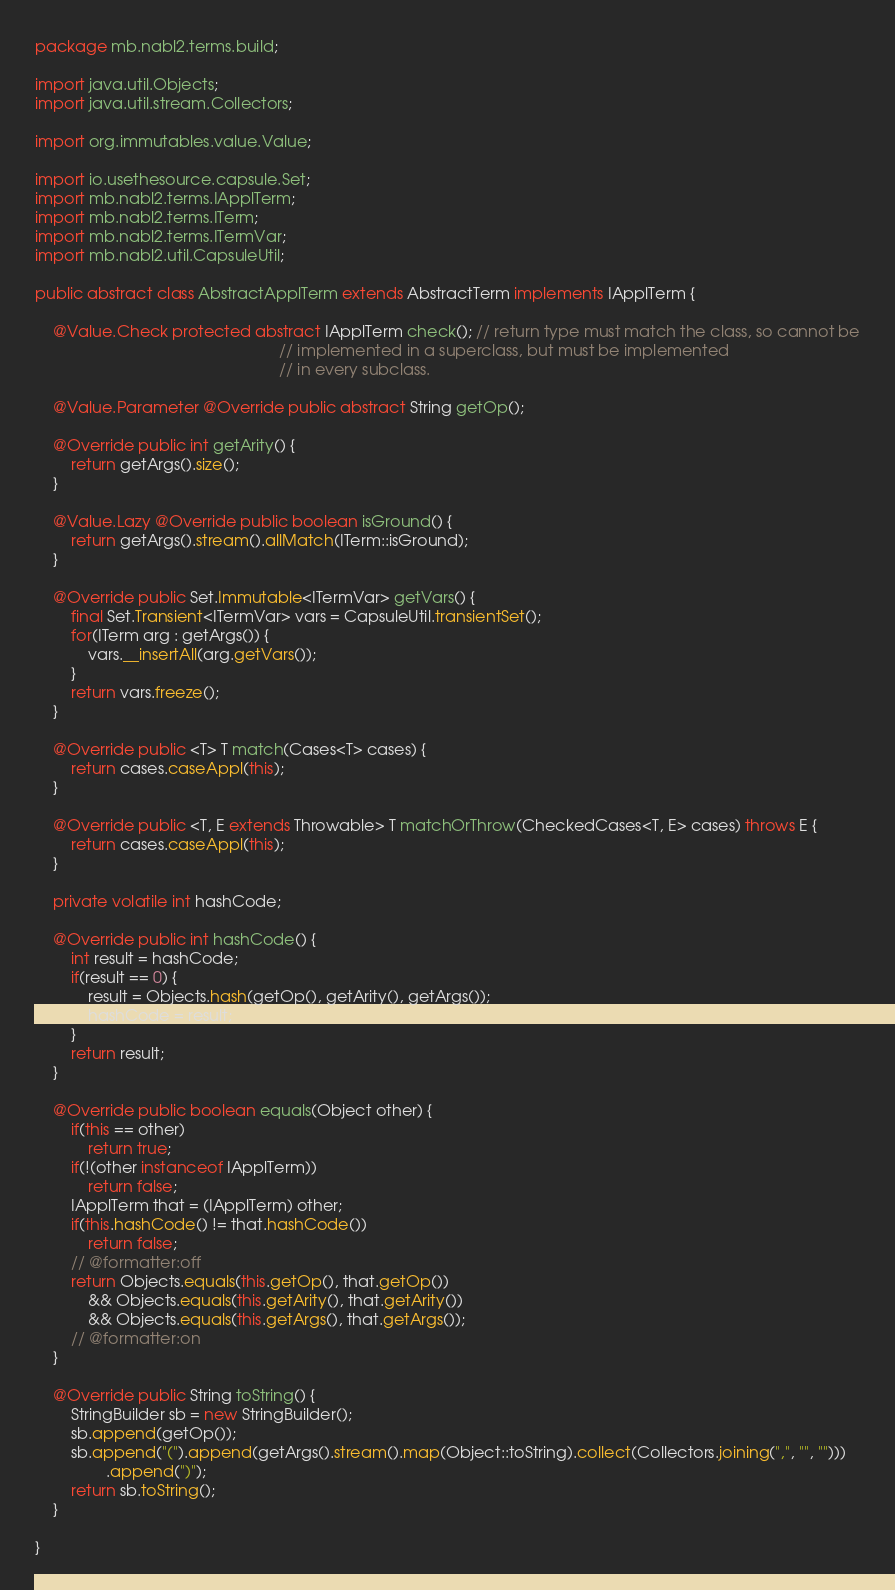Convert code to text. <code><loc_0><loc_0><loc_500><loc_500><_Java_>package mb.nabl2.terms.build;

import java.util.Objects;
import java.util.stream.Collectors;

import org.immutables.value.Value;

import io.usethesource.capsule.Set;
import mb.nabl2.terms.IApplTerm;
import mb.nabl2.terms.ITerm;
import mb.nabl2.terms.ITermVar;
import mb.nabl2.util.CapsuleUtil;

public abstract class AbstractApplTerm extends AbstractTerm implements IApplTerm {

    @Value.Check protected abstract IApplTerm check(); // return type must match the class, so cannot be
                                                       // implemented in a superclass, but must be implemented
                                                       // in every subclass.

    @Value.Parameter @Override public abstract String getOp();

    @Override public int getArity() {
        return getArgs().size();
    }

    @Value.Lazy @Override public boolean isGround() {
        return getArgs().stream().allMatch(ITerm::isGround);
    }

    @Override public Set.Immutable<ITermVar> getVars() {
        final Set.Transient<ITermVar> vars = CapsuleUtil.transientSet();
        for(ITerm arg : getArgs()) {
            vars.__insertAll(arg.getVars());
        }
        return vars.freeze();
    }

    @Override public <T> T match(Cases<T> cases) {
        return cases.caseAppl(this);
    }

    @Override public <T, E extends Throwable> T matchOrThrow(CheckedCases<T, E> cases) throws E {
        return cases.caseAppl(this);
    }

    private volatile int hashCode;

    @Override public int hashCode() {
        int result = hashCode;
        if(result == 0) {
            result = Objects.hash(getOp(), getArity(), getArgs());
            hashCode = result;
        }
        return result;
    }

    @Override public boolean equals(Object other) {
        if(this == other)
            return true;
        if(!(other instanceof IApplTerm))
            return false;
        IApplTerm that = (IApplTerm) other;
        if(this.hashCode() != that.hashCode())
            return false;
        // @formatter:off
        return Objects.equals(this.getOp(), that.getOp())
            && Objects.equals(this.getArity(), that.getArity())
            && Objects.equals(this.getArgs(), that.getArgs());
        // @formatter:on
    }

    @Override public String toString() {
        StringBuilder sb = new StringBuilder();
        sb.append(getOp());
        sb.append("(").append(getArgs().stream().map(Object::toString).collect(Collectors.joining(",", "", "")))
                .append(")");
        return sb.toString();
    }

}
</code> 